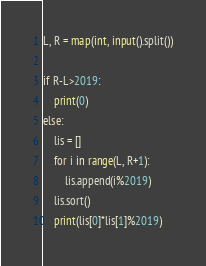Convert code to text. <code><loc_0><loc_0><loc_500><loc_500><_Python_>L, R = map(int, input().split())

if R-L>2019:
    print(0)
else:
    lis = []
    for i in range(L, R+1):
        lis.append(i%2019)
    lis.sort()
    print(lis[0]*lis[1]%2019)</code> 